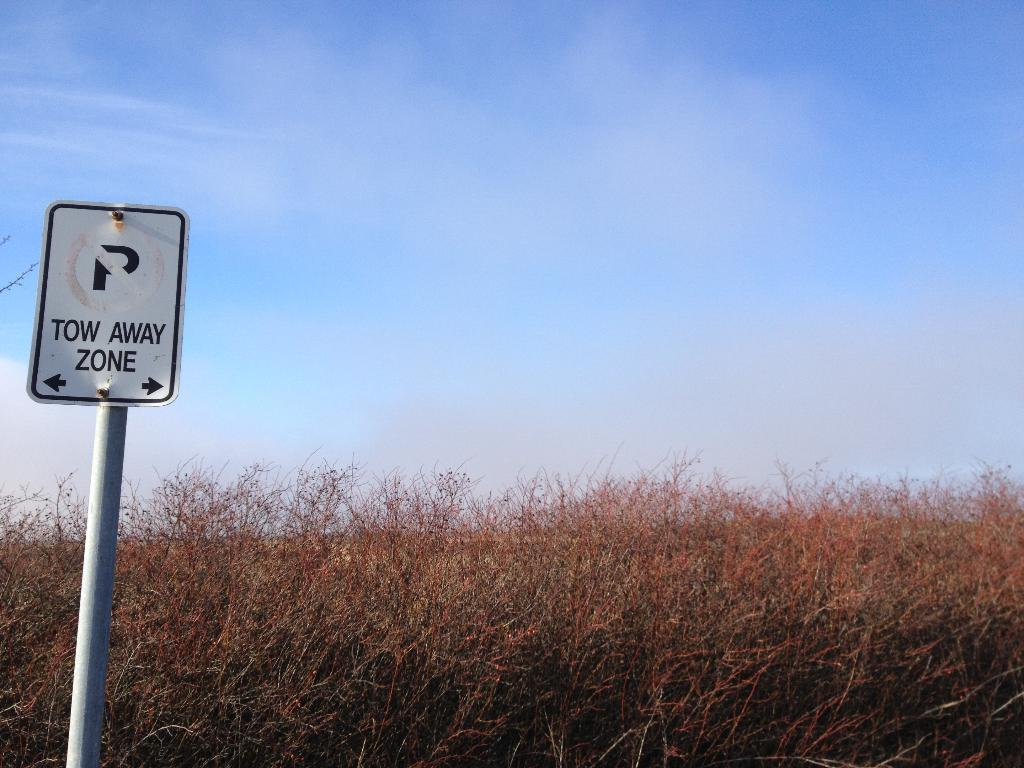What type of plants can be seen on the ground in the image? There are dry plants on the ground in the image. What else is present in the image besides the dry plants? There is a sign board in the image. What can be seen in the sky at the top of the image? The sky is clear and visible at the top of the image. What type of reaction can be seen on the wrist of the person in the image? There is no person present in the image, so it's not possible to determine any reactions on their wrist. What color is the balloon in the image? There is no balloon present in the image. 